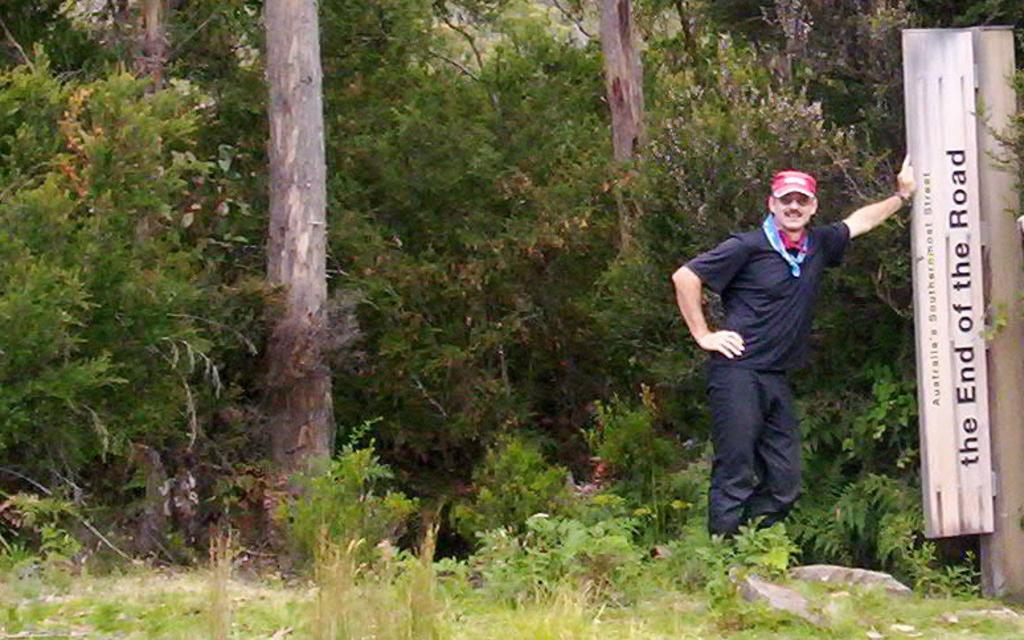What is the main subject of the image? There is a man standing in the image. What is the man wearing? The man is wearing a black shirt and a pant. What can be seen in the background of the image? There are plants and trees in the background of the image. How many cakes are on the man's head in the image? There are no cakes present on the man's head in the image. What type of trick is the man performing in the image? There is no trick being performed by the man in the image; he is simply standing. 